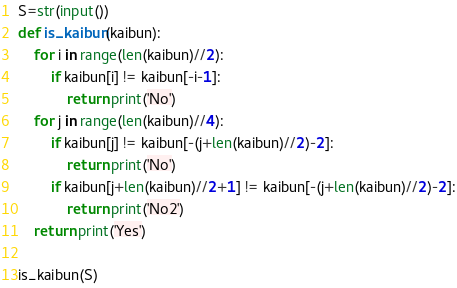Convert code to text. <code><loc_0><loc_0><loc_500><loc_500><_Python_>S=str(input())
def is_kaibun(kaibun):
    for i in range(len(kaibun)//2):
        if kaibun[i] != kaibun[-i-1]:
            return print('No')
    for j in range(len(kaibun)//4):
        if kaibun[j] != kaibun[-(j+len(kaibun)//2)-2]:
            return print('No')
        if kaibun[j+len(kaibun)//2+1] != kaibun[-(j+len(kaibun)//2)-2]:
            return print('No2')
    return print('Yes')

is_kaibun(S)</code> 